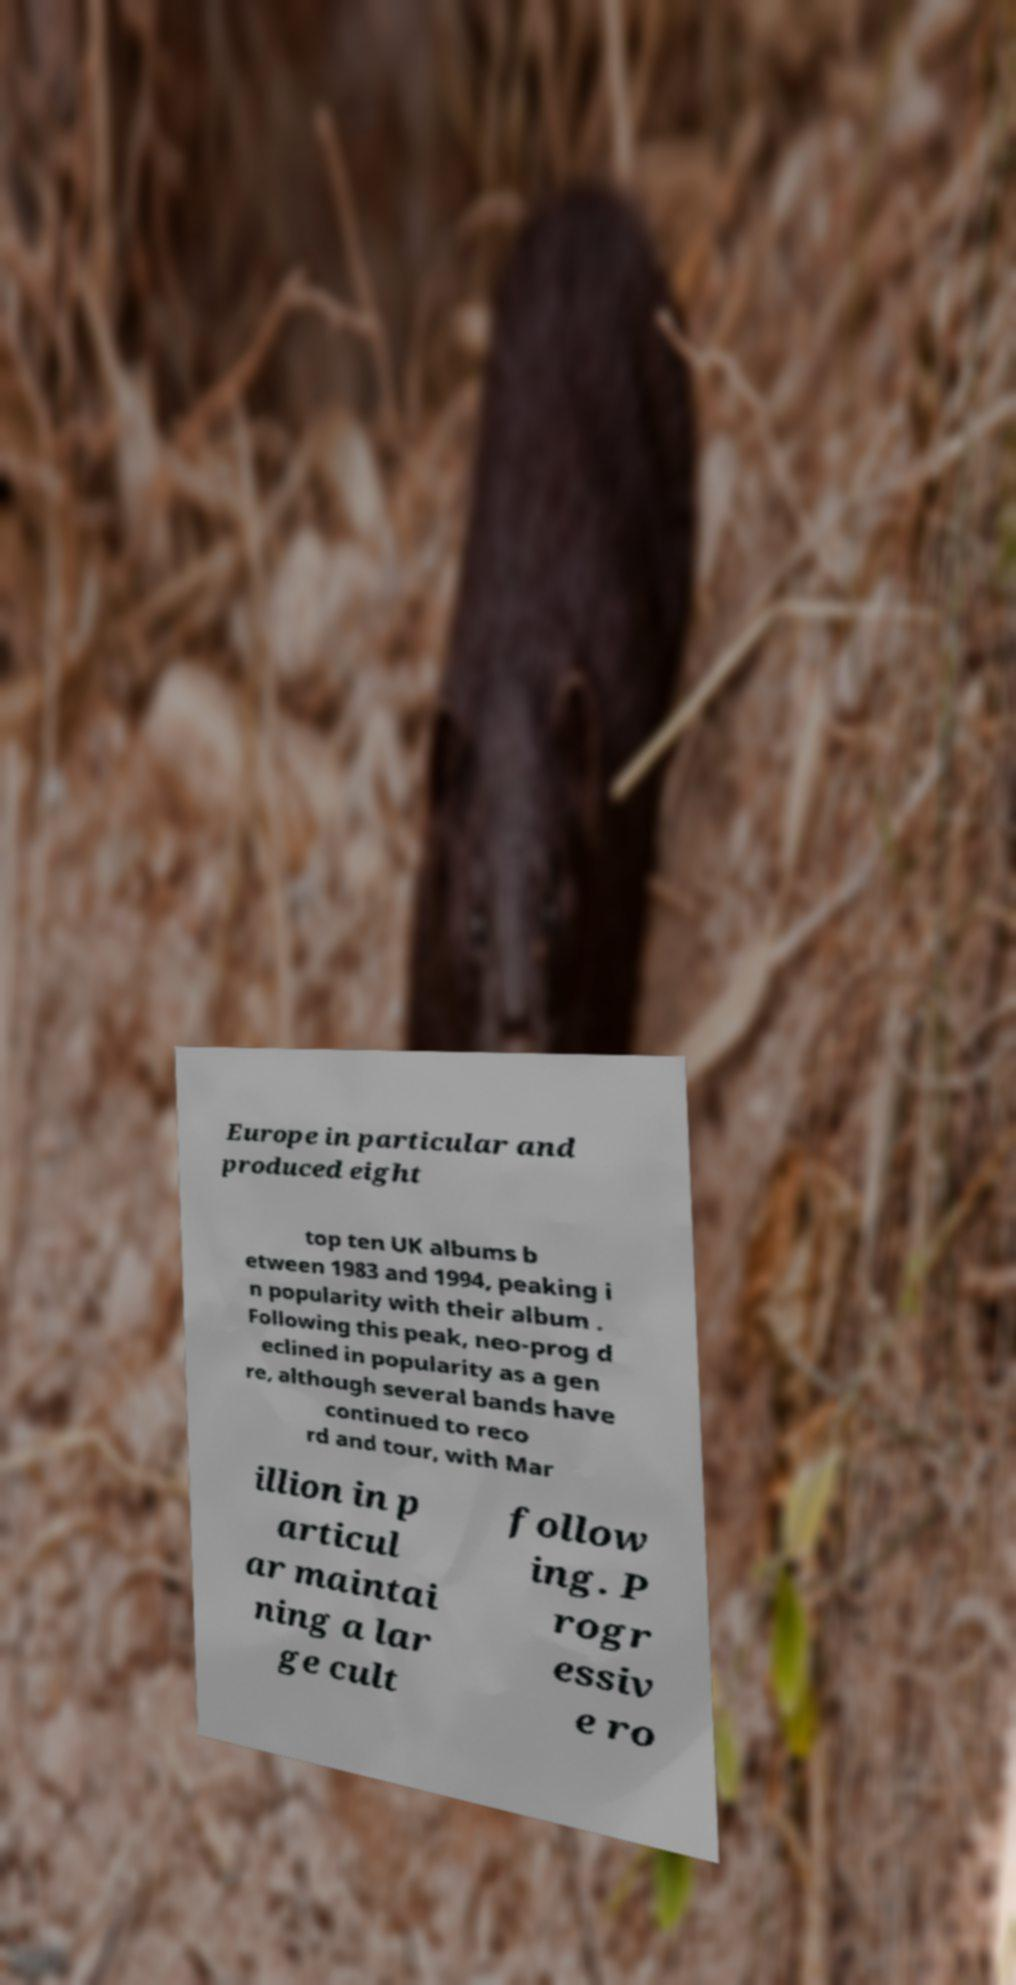I need the written content from this picture converted into text. Can you do that? Europe in particular and produced eight top ten UK albums b etween 1983 and 1994, peaking i n popularity with their album . Following this peak, neo-prog d eclined in popularity as a gen re, although several bands have continued to reco rd and tour, with Mar illion in p articul ar maintai ning a lar ge cult follow ing. P rogr essiv e ro 